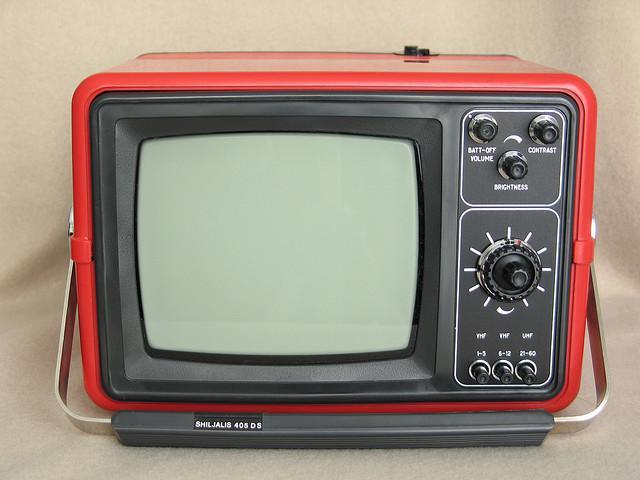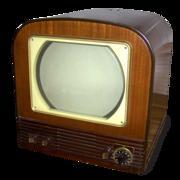The first image is the image on the left, the second image is the image on the right. For the images shown, is this caption "In one image, a TV has a screen with left and right sides that are curved outward and a flat top and bottom." true? Answer yes or no. Yes. 